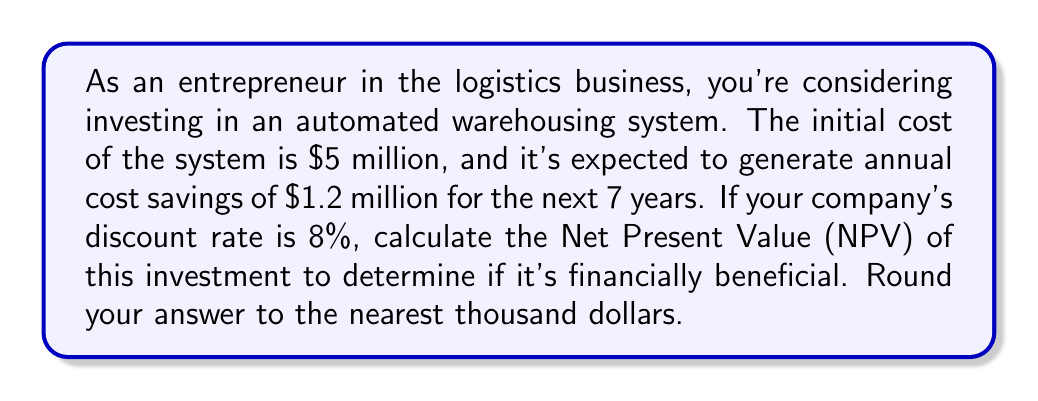Can you solve this math problem? To solve this problem, we'll use the Net Present Value (NPV) formula:

$$NPV = -C_0 + \sum_{t=1}^n \frac{C_t}{(1+r)^t}$$

Where:
$C_0$ = Initial investment
$C_t$ = Cash flow at time t
$r$ = Discount rate
$n$ = Number of periods

Given:
$C_0 = \$5,000,000$
$C_t = \$1,200,000$ (annual cost savings)
$r = 8\% = 0.08$
$n = 7$ years

Let's calculate the present value of each year's cash flow:

Year 1: $\frac{\$1,200,000}{(1+0.08)^1} = \$1,111,111$
Year 2: $\frac{\$1,200,000}{(1+0.08)^2} = \$1,028,807$
Year 3: $\frac{\$1,200,000}{(1+0.08)^3} = \$952,599$
Year 4: $\frac{\$1,200,000}{(1+0.08)^4} = \$882,036$
Year 5: $\frac{\$1,200,000}{(1+0.08)^5} = \$816,700$
Year 6: $\frac{\$1,200,000}{(1+0.08)^6} = \$756,204$
Year 7: $\frac{\$1,200,000}{(1+0.08)^7} = \$700,189$

Sum of present values: $\$6,247,646$

Now, we can calculate the NPV:

$$NPV = -\$5,000,000 + \$6,247,646 = \$1,247,646$$

Rounding to the nearest thousand:

$$NPV \approx \$1,248,000$$
Answer: $1,248,000 